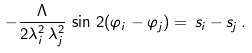Convert formula to latex. <formula><loc_0><loc_0><loc_500><loc_500>- \frac { \Lambda } { 2 \lambda _ { i } ^ { 2 } \, \lambda _ { j } ^ { 2 } } \, \sin \, 2 ( \varphi _ { i } - \varphi _ { j } ) = \, s _ { i } - s _ { j } \, .</formula> 